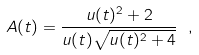<formula> <loc_0><loc_0><loc_500><loc_500>A ( t ) = \frac { u ( t ) ^ { 2 } + 2 } { u ( t ) \sqrt { u ( t ) ^ { 2 } + 4 } } \ ,</formula> 